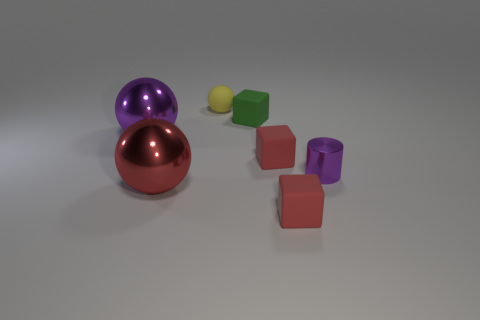How many big red shiny objects have the same shape as the tiny yellow thing?
Provide a succinct answer. 1. What is the yellow ball made of?
Offer a terse response. Rubber. Is the big purple metal object the same shape as the red metal thing?
Give a very brief answer. Yes. Are there any tiny yellow things that have the same material as the small yellow sphere?
Your answer should be very brief. No. The object that is left of the green thing and in front of the purple shiny cylinder is what color?
Offer a very short reply. Red. There is a ball behind the tiny green rubber object; what material is it?
Ensure brevity in your answer.  Rubber. Are there any other tiny things that have the same shape as the red metal thing?
Provide a short and direct response. Yes. What number of other things are the same shape as the yellow matte object?
Provide a succinct answer. 2. There is a small green matte object; does it have the same shape as the small red matte object behind the small metallic cylinder?
Provide a succinct answer. Yes. What is the material of the small yellow object that is the same shape as the large red metal thing?
Your answer should be compact. Rubber. 